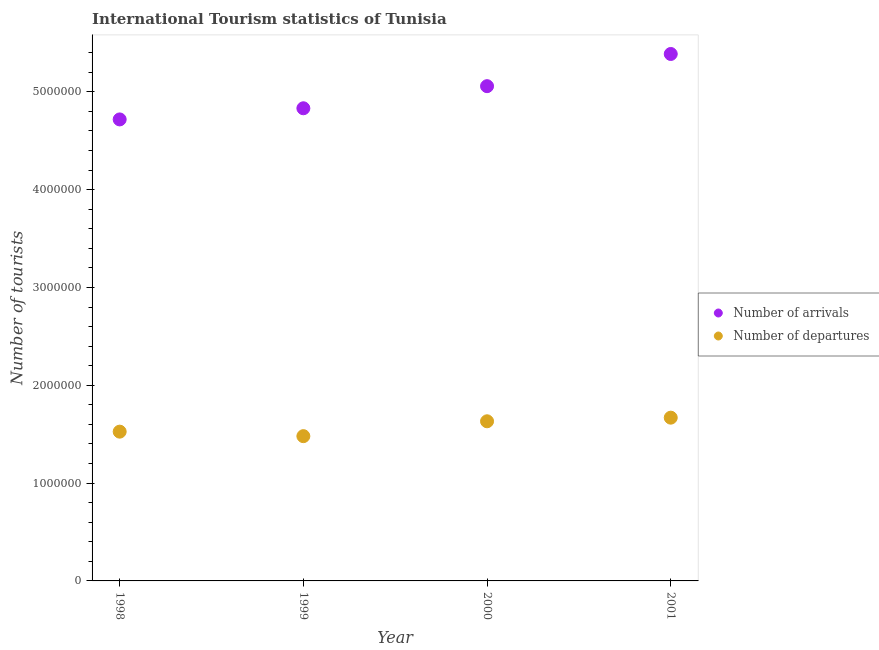How many different coloured dotlines are there?
Ensure brevity in your answer.  2. Is the number of dotlines equal to the number of legend labels?
Your response must be concise. Yes. What is the number of tourist departures in 1998?
Your answer should be compact. 1.53e+06. Across all years, what is the maximum number of tourist departures?
Make the answer very short. 1.67e+06. Across all years, what is the minimum number of tourist departures?
Give a very brief answer. 1.48e+06. What is the total number of tourist departures in the graph?
Ensure brevity in your answer.  6.31e+06. What is the difference between the number of tourist arrivals in 1998 and that in 1999?
Ensure brevity in your answer.  -1.14e+05. What is the difference between the number of tourist arrivals in 1999 and the number of tourist departures in 2000?
Keep it short and to the point. 3.20e+06. What is the average number of tourist arrivals per year?
Give a very brief answer. 5.00e+06. In the year 2001, what is the difference between the number of tourist arrivals and number of tourist departures?
Offer a very short reply. 3.72e+06. In how many years, is the number of tourist arrivals greater than 4800000?
Your answer should be very brief. 3. What is the ratio of the number of tourist departures in 1998 to that in 2000?
Offer a terse response. 0.94. Is the difference between the number of tourist departures in 1998 and 1999 greater than the difference between the number of tourist arrivals in 1998 and 1999?
Provide a succinct answer. Yes. What is the difference between the highest and the second highest number of tourist departures?
Give a very brief answer. 3.70e+04. What is the difference between the highest and the lowest number of tourist departures?
Keep it short and to the point. 1.89e+05. In how many years, is the number of tourist departures greater than the average number of tourist departures taken over all years?
Your answer should be compact. 2. Is the sum of the number of tourist departures in 1999 and 2000 greater than the maximum number of tourist arrivals across all years?
Keep it short and to the point. No. What is the difference between two consecutive major ticks on the Y-axis?
Your answer should be compact. 1.00e+06. Does the graph contain any zero values?
Provide a short and direct response. No. Does the graph contain grids?
Offer a terse response. No. Where does the legend appear in the graph?
Offer a very short reply. Center right. How are the legend labels stacked?
Provide a succinct answer. Vertical. What is the title of the graph?
Ensure brevity in your answer.  International Tourism statistics of Tunisia. What is the label or title of the Y-axis?
Your response must be concise. Number of tourists. What is the Number of tourists in Number of arrivals in 1998?
Keep it short and to the point. 4.72e+06. What is the Number of tourists of Number of departures in 1998?
Offer a very short reply. 1.53e+06. What is the Number of tourists in Number of arrivals in 1999?
Your answer should be compact. 4.83e+06. What is the Number of tourists of Number of departures in 1999?
Offer a very short reply. 1.48e+06. What is the Number of tourists of Number of arrivals in 2000?
Keep it short and to the point. 5.06e+06. What is the Number of tourists in Number of departures in 2000?
Keep it short and to the point. 1.63e+06. What is the Number of tourists in Number of arrivals in 2001?
Give a very brief answer. 5.39e+06. What is the Number of tourists in Number of departures in 2001?
Give a very brief answer. 1.67e+06. Across all years, what is the maximum Number of tourists of Number of arrivals?
Your response must be concise. 5.39e+06. Across all years, what is the maximum Number of tourists of Number of departures?
Make the answer very short. 1.67e+06. Across all years, what is the minimum Number of tourists of Number of arrivals?
Provide a succinct answer. 4.72e+06. Across all years, what is the minimum Number of tourists of Number of departures?
Provide a short and direct response. 1.48e+06. What is the total Number of tourists of Number of arrivals in the graph?
Ensure brevity in your answer.  2.00e+07. What is the total Number of tourists in Number of departures in the graph?
Provide a succinct answer. 6.31e+06. What is the difference between the Number of tourists in Number of arrivals in 1998 and that in 1999?
Provide a short and direct response. -1.14e+05. What is the difference between the Number of tourists in Number of departures in 1998 and that in 1999?
Offer a terse response. 4.60e+04. What is the difference between the Number of tourists of Number of arrivals in 1998 and that in 2000?
Make the answer very short. -3.40e+05. What is the difference between the Number of tourists of Number of departures in 1998 and that in 2000?
Offer a terse response. -1.06e+05. What is the difference between the Number of tourists of Number of arrivals in 1998 and that in 2001?
Offer a very short reply. -6.69e+05. What is the difference between the Number of tourists of Number of departures in 1998 and that in 2001?
Ensure brevity in your answer.  -1.43e+05. What is the difference between the Number of tourists of Number of arrivals in 1999 and that in 2000?
Give a very brief answer. -2.26e+05. What is the difference between the Number of tourists in Number of departures in 1999 and that in 2000?
Provide a succinct answer. -1.52e+05. What is the difference between the Number of tourists of Number of arrivals in 1999 and that in 2001?
Keep it short and to the point. -5.55e+05. What is the difference between the Number of tourists of Number of departures in 1999 and that in 2001?
Your response must be concise. -1.89e+05. What is the difference between the Number of tourists of Number of arrivals in 2000 and that in 2001?
Your response must be concise. -3.29e+05. What is the difference between the Number of tourists of Number of departures in 2000 and that in 2001?
Make the answer very short. -3.70e+04. What is the difference between the Number of tourists of Number of arrivals in 1998 and the Number of tourists of Number of departures in 1999?
Your answer should be very brief. 3.24e+06. What is the difference between the Number of tourists in Number of arrivals in 1998 and the Number of tourists in Number of departures in 2000?
Your answer should be compact. 3.09e+06. What is the difference between the Number of tourists of Number of arrivals in 1998 and the Number of tourists of Number of departures in 2001?
Your answer should be very brief. 3.05e+06. What is the difference between the Number of tourists in Number of arrivals in 1999 and the Number of tourists in Number of departures in 2000?
Offer a terse response. 3.20e+06. What is the difference between the Number of tourists of Number of arrivals in 1999 and the Number of tourists of Number of departures in 2001?
Your response must be concise. 3.16e+06. What is the difference between the Number of tourists of Number of arrivals in 2000 and the Number of tourists of Number of departures in 2001?
Offer a very short reply. 3.39e+06. What is the average Number of tourists of Number of arrivals per year?
Make the answer very short. 5.00e+06. What is the average Number of tourists in Number of departures per year?
Make the answer very short. 1.58e+06. In the year 1998, what is the difference between the Number of tourists in Number of arrivals and Number of tourists in Number of departures?
Offer a terse response. 3.19e+06. In the year 1999, what is the difference between the Number of tourists of Number of arrivals and Number of tourists of Number of departures?
Your response must be concise. 3.35e+06. In the year 2000, what is the difference between the Number of tourists of Number of arrivals and Number of tourists of Number of departures?
Keep it short and to the point. 3.43e+06. In the year 2001, what is the difference between the Number of tourists in Number of arrivals and Number of tourists in Number of departures?
Ensure brevity in your answer.  3.72e+06. What is the ratio of the Number of tourists of Number of arrivals in 1998 to that in 1999?
Offer a very short reply. 0.98. What is the ratio of the Number of tourists of Number of departures in 1998 to that in 1999?
Offer a terse response. 1.03. What is the ratio of the Number of tourists in Number of arrivals in 1998 to that in 2000?
Keep it short and to the point. 0.93. What is the ratio of the Number of tourists in Number of departures in 1998 to that in 2000?
Your response must be concise. 0.94. What is the ratio of the Number of tourists of Number of arrivals in 1998 to that in 2001?
Ensure brevity in your answer.  0.88. What is the ratio of the Number of tourists of Number of departures in 1998 to that in 2001?
Make the answer very short. 0.91. What is the ratio of the Number of tourists in Number of arrivals in 1999 to that in 2000?
Provide a short and direct response. 0.96. What is the ratio of the Number of tourists in Number of departures in 1999 to that in 2000?
Provide a succinct answer. 0.91. What is the ratio of the Number of tourists in Number of arrivals in 1999 to that in 2001?
Make the answer very short. 0.9. What is the ratio of the Number of tourists of Number of departures in 1999 to that in 2001?
Provide a short and direct response. 0.89. What is the ratio of the Number of tourists in Number of arrivals in 2000 to that in 2001?
Make the answer very short. 0.94. What is the ratio of the Number of tourists in Number of departures in 2000 to that in 2001?
Your answer should be very brief. 0.98. What is the difference between the highest and the second highest Number of tourists of Number of arrivals?
Your answer should be very brief. 3.29e+05. What is the difference between the highest and the second highest Number of tourists of Number of departures?
Your response must be concise. 3.70e+04. What is the difference between the highest and the lowest Number of tourists in Number of arrivals?
Your answer should be very brief. 6.69e+05. What is the difference between the highest and the lowest Number of tourists in Number of departures?
Ensure brevity in your answer.  1.89e+05. 